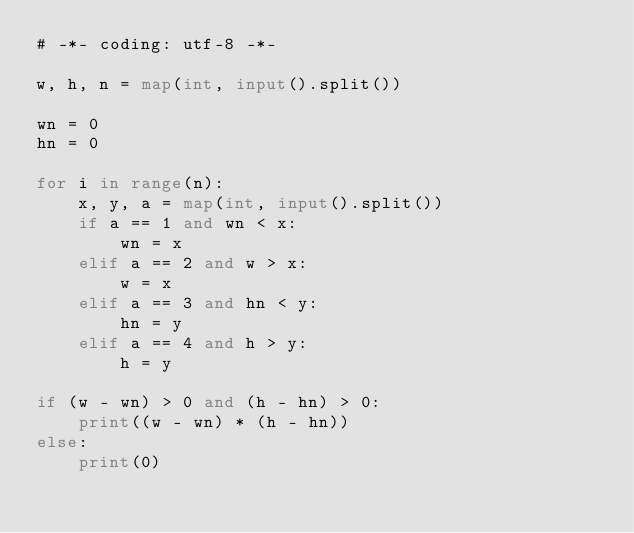Convert code to text. <code><loc_0><loc_0><loc_500><loc_500><_Python_># -*- coding: utf-8 -*-

w, h, n = map(int, input().split())

wn = 0
hn = 0

for i in range(n):
    x, y, a = map(int, input().split())
    if a == 1 and wn < x:
        wn = x
    elif a == 2 and w > x:
        w = x        
    elif a == 3 and hn < y:
        hn = y
    elif a == 4 and h > y:
        h = y

if (w - wn) > 0 and (h - hn) > 0:
    print((w - wn) * (h - hn))
else:
    print(0)
</code> 